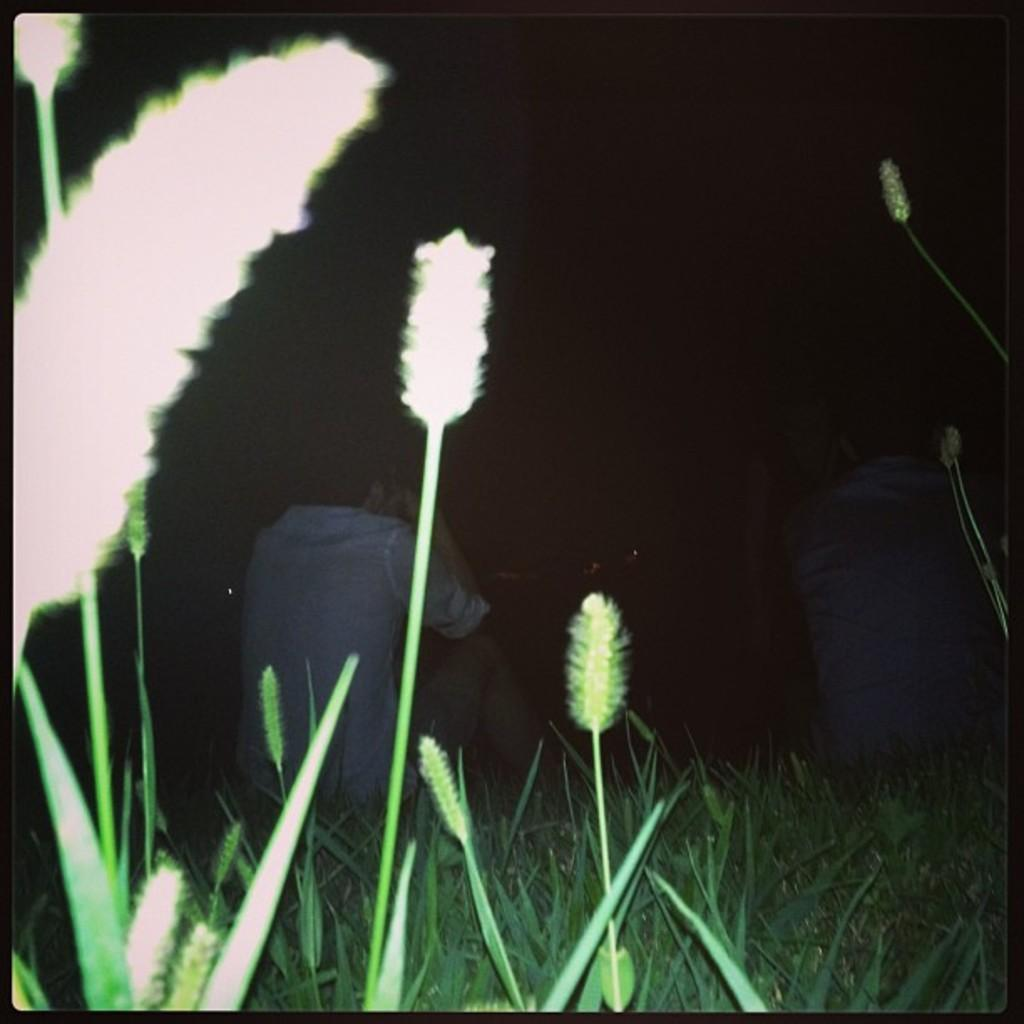What is located in the front of the image? There are people and plants in the front of the image. Can you describe the people in the image? The provided facts do not give specific details about the people, but they are present in the front of the image. What can be seen in the background of the image? The background of the image is dark. How many times do the people in the image jump in the air? The provided facts do not mention any jumping or specific actions of the people in the image. What type of coat is the person in the image wearing? The provided facts do not mention any coats or specific clothing items worn by the people in the image. 